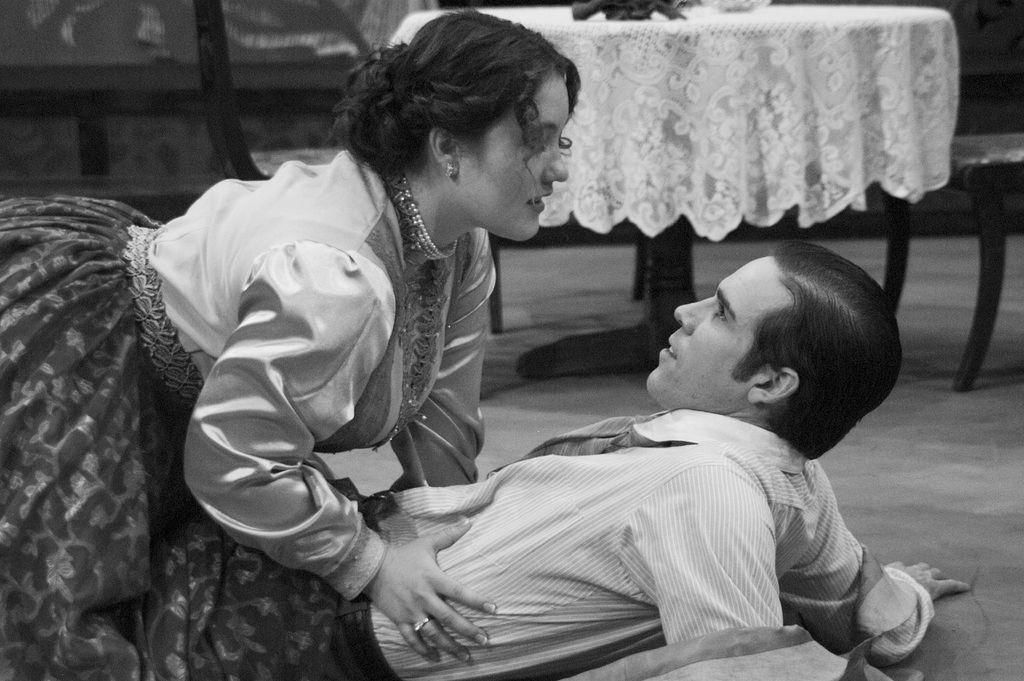Can you describe this image briefly? This is a black and white image as we can see there is one person lying on the ground. There is one women on the left side of this image. There is a dining table at the top of this image. 